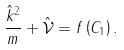<formula> <loc_0><loc_0><loc_500><loc_500>\frac { \hat { k } ^ { 2 } } { m } + \mathcal { \hat { V } } = f \left ( C _ { 1 } \right ) .</formula> 